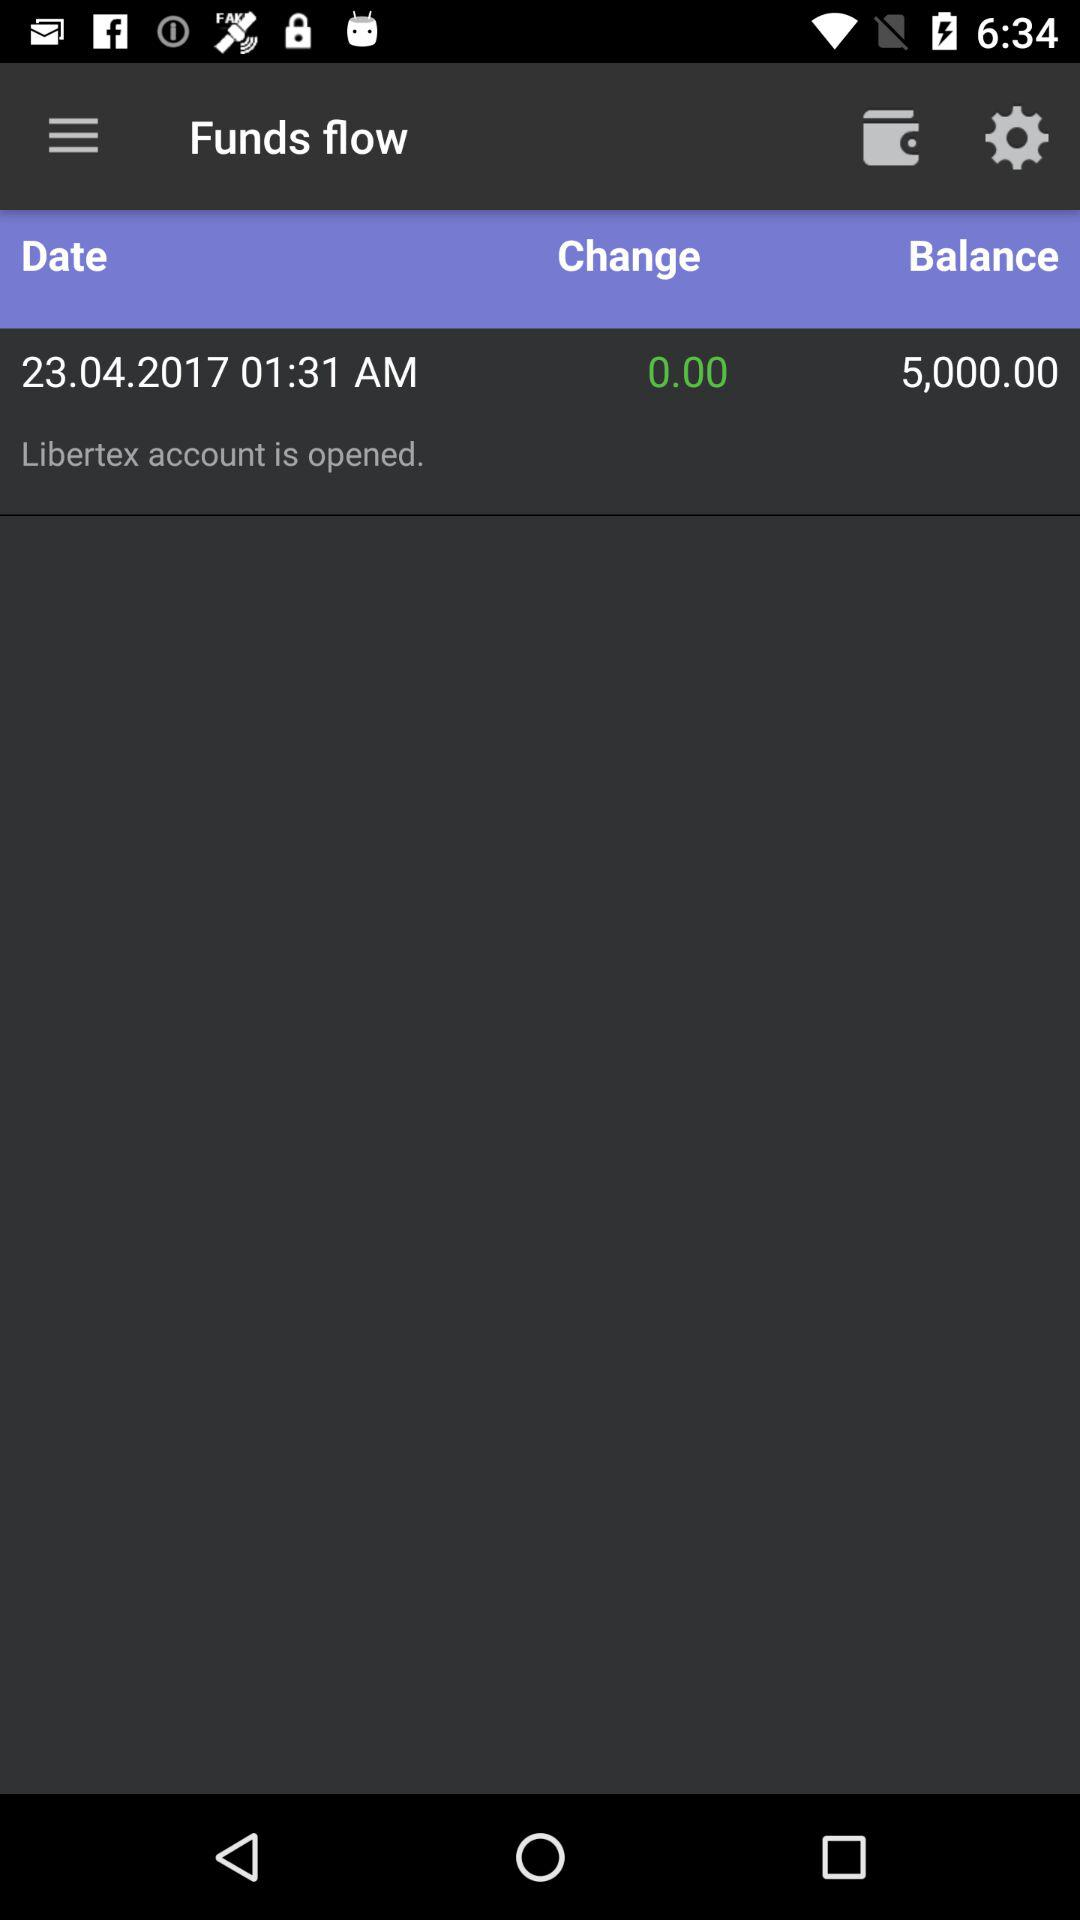What is the change? The change is 0.00. 